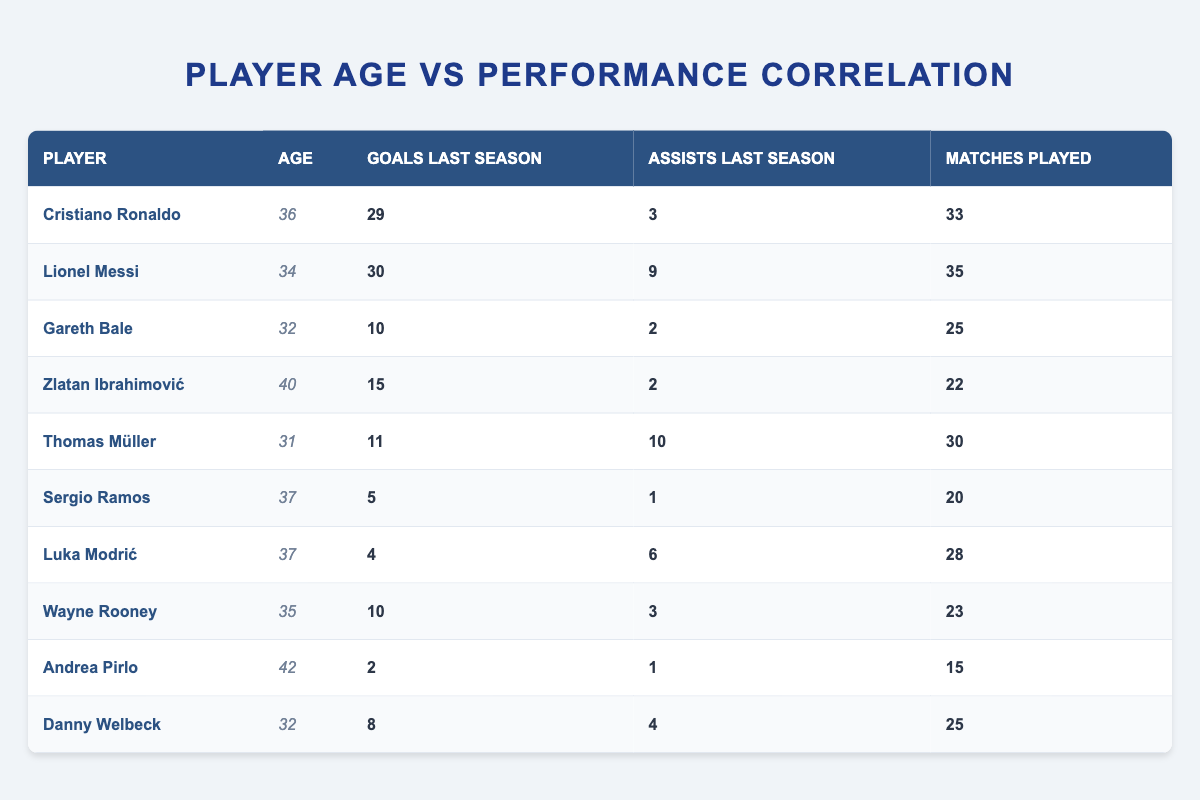What is the age of Lionel Messi? The table lists Lionel Messi's information in the second row, and his age is explicitly stated as 34.
Answer: 34 Who scored the least number of goals last season among the players in the table? By examining the "Goals Last Season" column, Andrea Pirlo scored the least with 2 goals.
Answer: Andrea Pirlo How many players are aged 37 or older? By filtering the table for ages 37 and above, I find Sergio Ramos (37), Luka Modrić (37), Zlatan Ibrahimović (40), and Andrea Pirlo (42), totaling 4 players.
Answer: 4 What is the average number of goals scored by players aged 32 and under? The players aged 32 and under are Gareth Bale (10), Thomas Müller (11), and Danny Welbeck (8). The total goals scored are 10 + 11 + 8 = 29. Dividing by the number of players (3) gives an average of 29/3 = 9.67.
Answer: 9.67 Is it true that all players aged 36 or older scored fewer than 20 goals last season? Analyzing the players aged 36 or older, I see Cristiano Ronaldo (29), Sergio Ramos (5), Luka Modrić (4), Zlatan Ibrahimović (15), Wayne Rooney (10), and Andrea Pirlo (2). Cristiano Ronaldo scored more than 20 goals, so the statement is false.
Answer: No Which player has the highest assists last season, and what was the number? By reviewing the "Assists Last Season" column, Lionel Messi has the highest assists, scoring 9.
Answer: Lionel Messi, 9 How many total assists did players aged 37 and older provide last season? Players aged 37 and older are Sergio Ramos (1), Luka Modrić (6), Zlatan Ibrahimović (2), and Andrea Pirlo (1). The total assists are calculated as 1 + 6 + 2 + 1 = 10.
Answer: 10 What is the difference in goals scored last season between the oldest and youngest players in the table? The oldest player, Andrea Pirlo, scored 2 goals, while the youngest players (Gareth Bale, Thomas Müller, Danny Welbeck) scored 10, 11, and 8 respectively. The maximum from this group is 11. Thus, the difference is 11 - 2 = 9.
Answer: 9 Which player had the highest number of matches played last season? By looking at the "Matches Played" column, Lionel Messi played the most matches, totaling 35.
Answer: Lionel Messi 